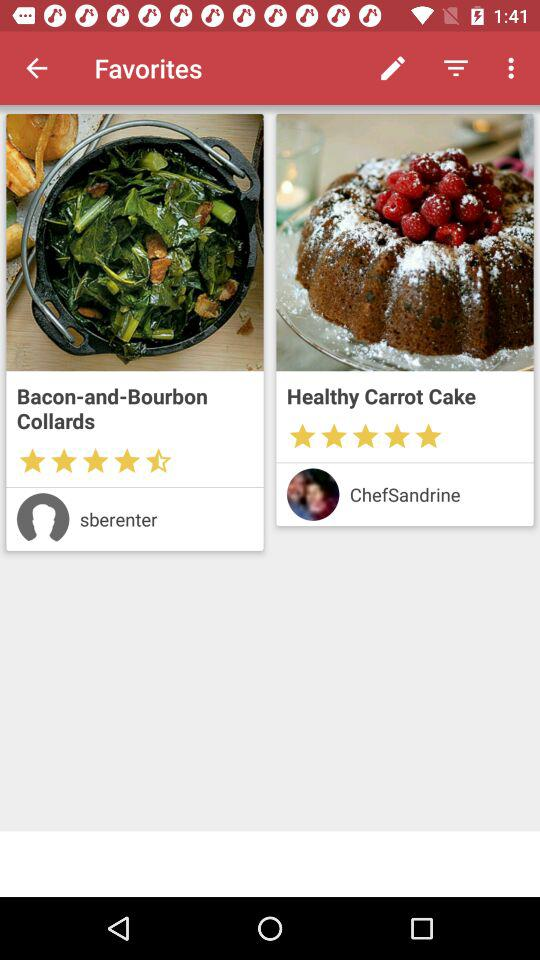Who made the "Bacon-and-Bourbon Collards"? The "Bacon-and-Bourbon Collards" is made by "sberenter". 